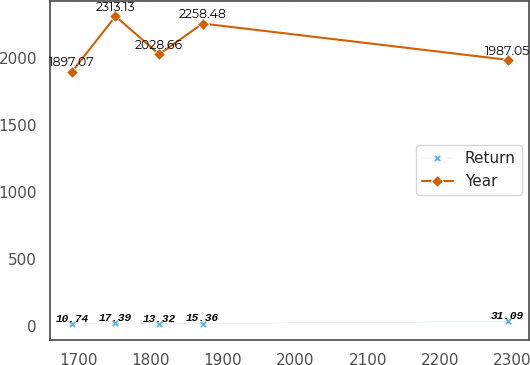Convert chart. <chart><loc_0><loc_0><loc_500><loc_500><line_chart><ecel><fcel>Return<fcel>Year<nl><fcel>1690.86<fcel>10.74<fcel>1897.07<nl><fcel>1751.14<fcel>17.39<fcel>2313.13<nl><fcel>1811.42<fcel>13.32<fcel>2028.66<nl><fcel>1871.7<fcel>15.36<fcel>2258.48<nl><fcel>2293.7<fcel>31.09<fcel>1987.05<nl></chart> 